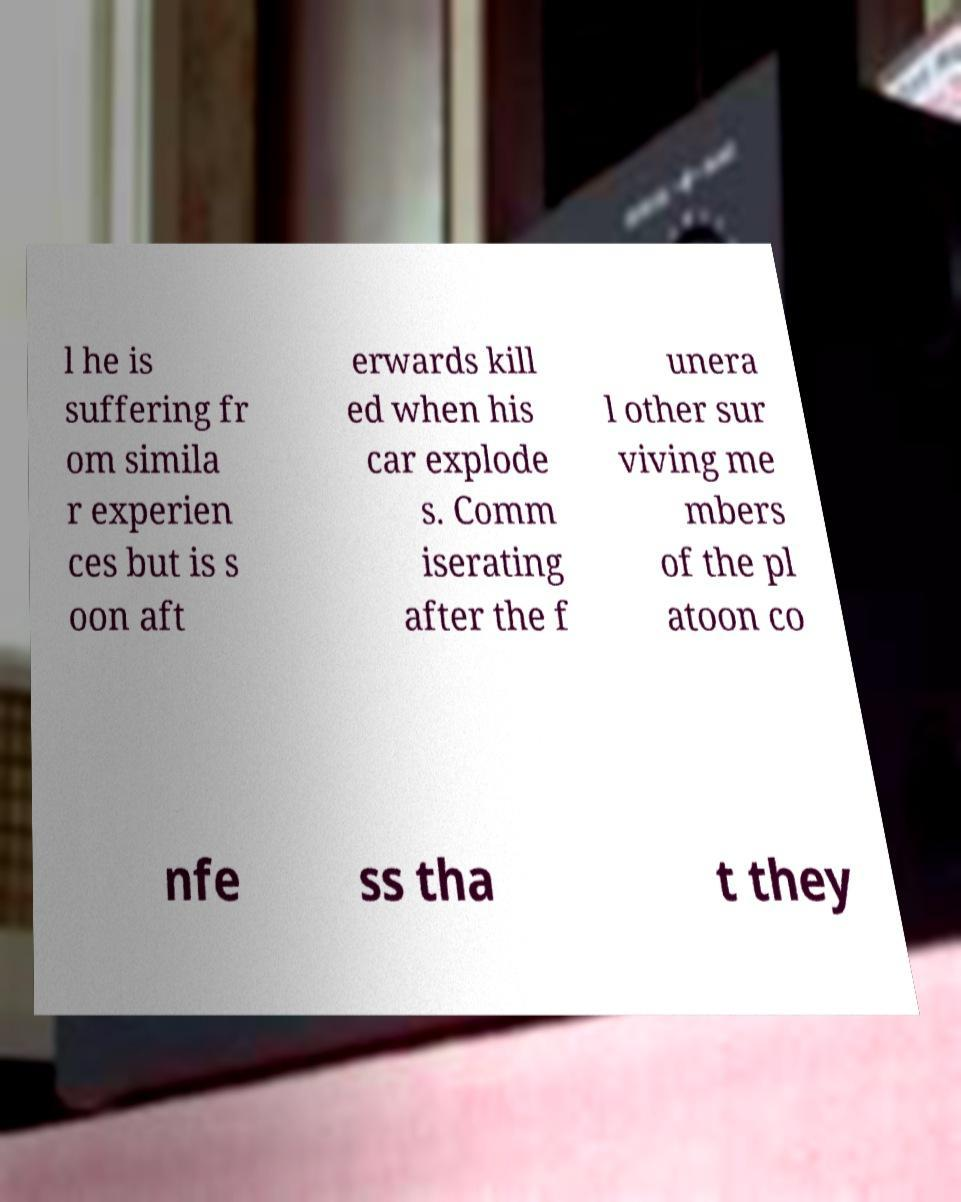Can you accurately transcribe the text from the provided image for me? l he is suffering fr om simila r experien ces but is s oon aft erwards kill ed when his car explode s. Comm iserating after the f unera l other sur viving me mbers of the pl atoon co nfe ss tha t they 